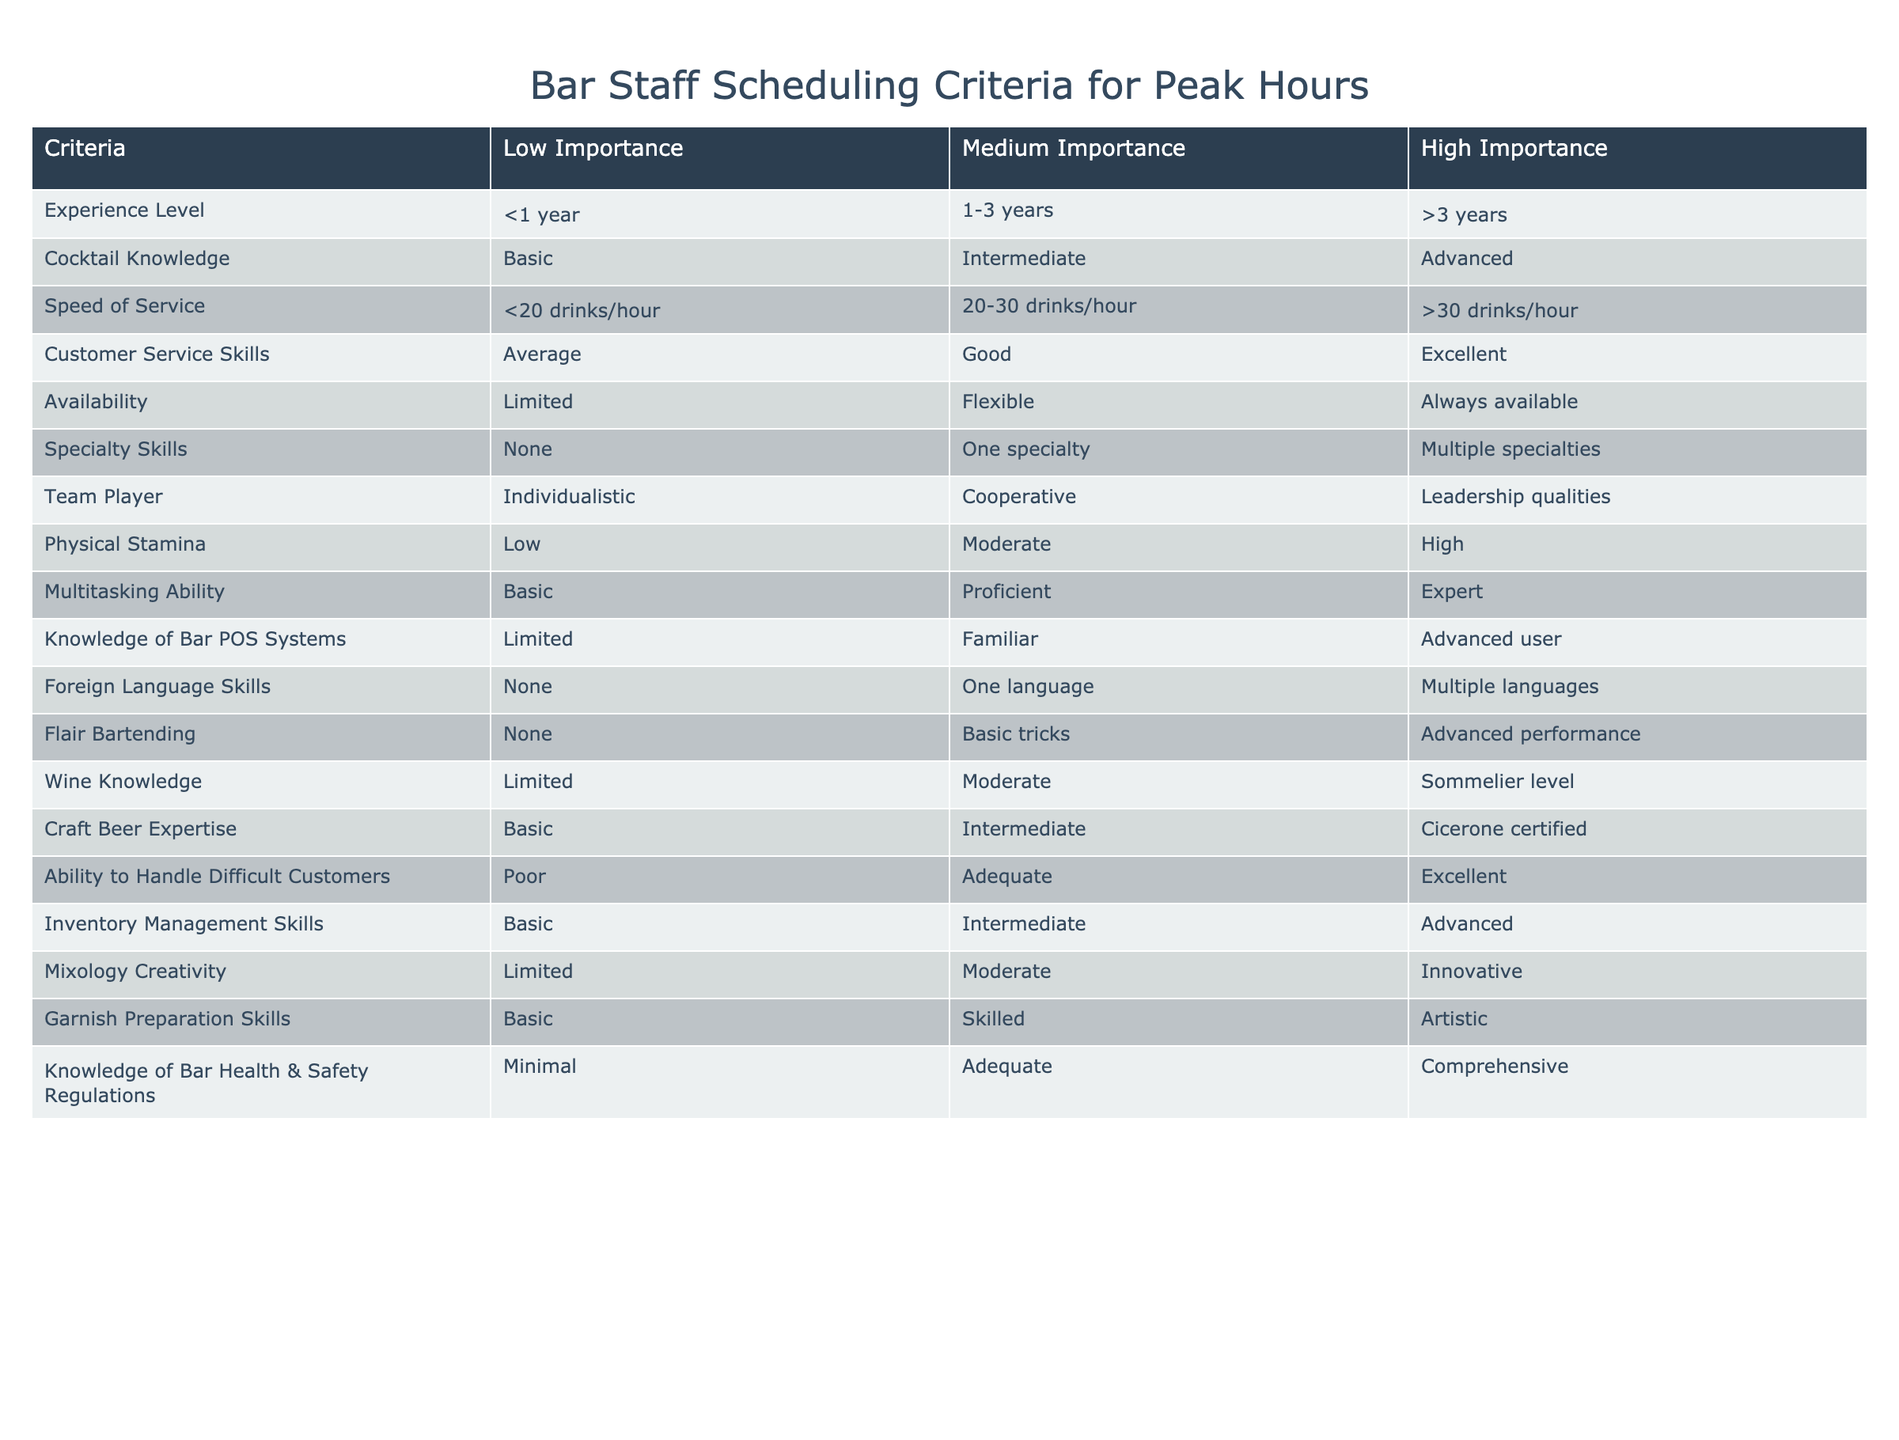What is the experience level categorized as high importance? Under high importance, the experience level is defined as being greater than 3 years. This can be found in the "Experience Level" row under the "High Importance" column.
Answer: Greater than 3 years Which criterion is categorized as having low physical stamina? The physical stamina criterion categorized as low importance is "Low". This information is present in the "Physical Stamina" row under the "Low Importance" column.
Answer: Low Is it necessary for bar staff to have advanced knowledge of bar POS systems? Yes, having advanced knowledge of bar POS systems is categorized under high importance, indicating that it is necessary for bar staff. This is evident from the "Knowledge of Bar POS Systems" row under the "High Importance" column.
Answer: Yes What are the average criteria ratings for customer service skills? To find the average rating, we need to consider that the customer service skills categorize as "Average" for low, "Good" for medium, and "Excellent" for high importance. Taking their ordinal values, if we assign 1 for low, 2 for medium, and 3 for high, the average would be (1 + 2 + 3) / 3 = 2, which corresponds to a medium rating.
Answer: Medium Which combination of skills is most flexible in scheduling? The availability criterion categorized under high importance is defined as "Always available", indicating that this skill is most flexible in scheduling. This can be identified in the "Availability" row under the "High Importance" column.
Answer: Always available What is the difference in importance between basic and advanced cocktail knowledge? The importance of "Basic" cocktail knowledge is categorized as low while "Advanced" cocktail knowledge is categorized as high. The difference between low and high importance indicates that advanced cocktail knowledge holds significantly greater value for scheduling. This can be seen by comparing the two rows for cocktail knowledge.
Answer: Advanced is more important Are multiple specialties important for staffing decisions? Yes, having multiple specialties falls under high importance within the specialty skills criterion, indicating that it is favored for staffing decisions. This is visible in the “Specialty Skills” row under the “High Importance” column.
Answer: Yes Which skills are equally necessary among both average and excellent ability? The ability to handle difficult customers has been noted under low (poor), medium (adequate), and high (excellent) ratings. However, the distinction in importance shows that "Excellent" is influential for scheduling, whereas "Average" isn’t. Skills cannot be equated equally necessary since high skills trump average skills.
Answer: No What is the highest level of experience classified as low importance? The experience level classified as low importance is "<1 year", which indicates that staff with less than one year of experience are considered less critical in scheduling peak hours. This is captured in the "Experience Level" row under the "Low Importance" column.
Answer: <1 year 